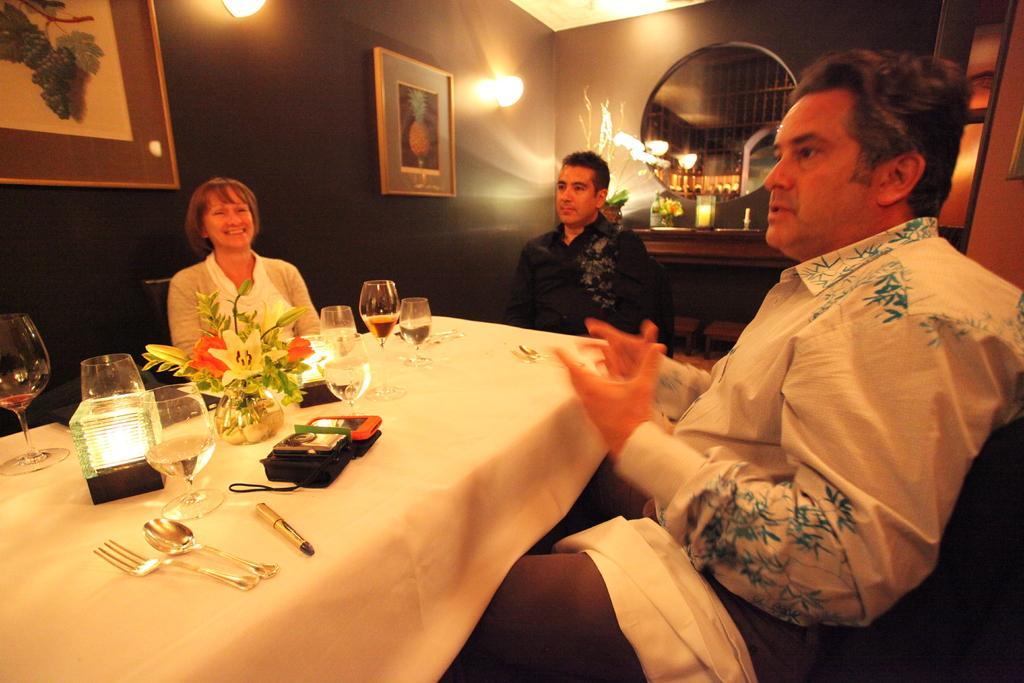Please provide a concise description of this image. In this image I see a woman who is smiling and I see 2 men and all of them are sitting and there is a table on which there are many glasses, a light and spoon and a fork on it. In the background I see the photo frames, lights and a plant. 